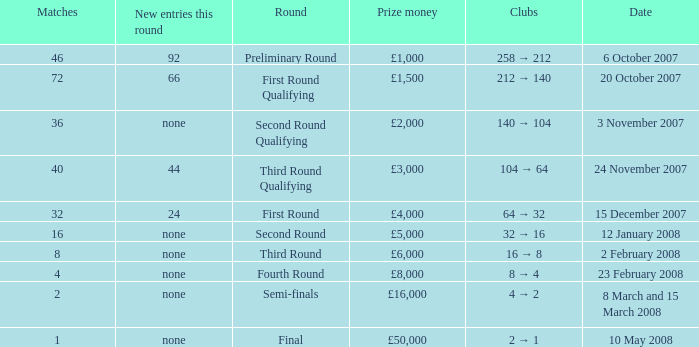How many new entries this round are there with more than 16 matches and a third round qualifying? 44.0. Give me the full table as a dictionary. {'header': ['Matches', 'New entries this round', 'Round', 'Prize money', 'Clubs', 'Date'], 'rows': [['46', '92', 'Preliminary Round', '£1,000', '258 → 212', '6 October 2007'], ['72', '66', 'First Round Qualifying', '£1,500', '212 → 140', '20 October 2007'], ['36', 'none', 'Second Round Qualifying', '£2,000', '140 → 104', '3 November 2007'], ['40', '44', 'Third Round Qualifying', '£3,000', '104 → 64', '24 November 2007'], ['32', '24', 'First Round', '£4,000', '64 → 32', '15 December 2007'], ['16', 'none', 'Second Round', '£5,000', '32 → 16', '12 January 2008'], ['8', 'none', 'Third Round', '£6,000', '16 → 8', '2 February 2008'], ['4', 'none', 'Fourth Round', '£8,000', '8 → 4', '23 February 2008'], ['2', 'none', 'Semi-finals', '£16,000', '4 → 2', '8 March and 15 March 2008'], ['1', 'none', 'Final', '£50,000', '2 → 1', '10 May 2008']]} 